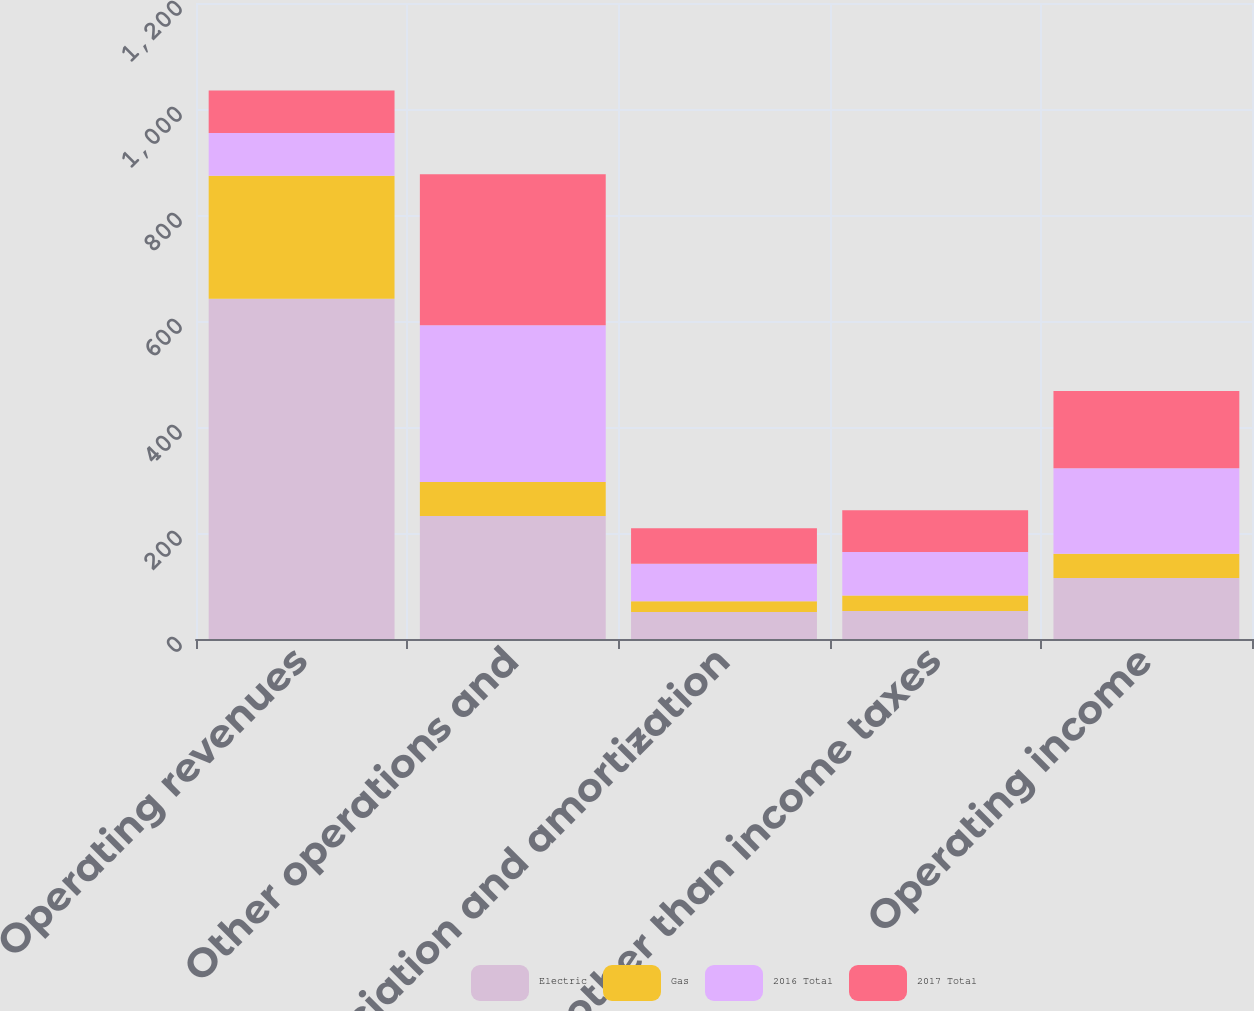Convert chart. <chart><loc_0><loc_0><loc_500><loc_500><stacked_bar_chart><ecel><fcel>Operating revenues<fcel>Other operations and<fcel>Depreciation and amortization<fcel>Taxes other than income taxes<fcel>Operating income<nl><fcel>Electric<fcel>642<fcel>232<fcel>51<fcel>53<fcel>115<nl><fcel>Gas<fcel>232<fcel>64<fcel>20<fcel>29<fcel>46<nl><fcel>2016 Total<fcel>80.5<fcel>296<fcel>71<fcel>82<fcel>161<nl><fcel>2017 Total<fcel>80.5<fcel>285<fcel>67<fcel>79<fcel>146<nl></chart> 